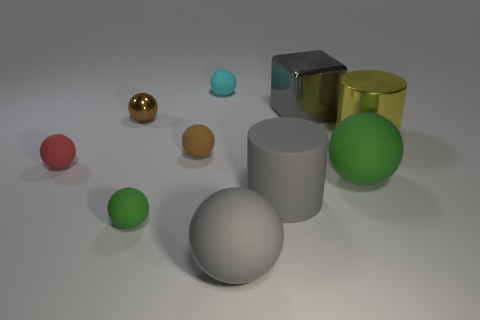There is a green matte sphere that is on the right side of the cyan ball; does it have the same size as the large gray sphere?
Offer a terse response. Yes. There is a big block; is it the same color as the large rubber sphere that is on the right side of the gray cube?
Provide a succinct answer. No. The rubber thing that is the same color as the rubber cylinder is what shape?
Offer a very short reply. Sphere. What is the shape of the tiny metallic thing?
Ensure brevity in your answer.  Sphere. Is the color of the shiny block the same as the shiny cylinder?
Make the answer very short. No. What number of objects are small objects that are to the right of the brown shiny ball or large rubber cylinders?
Give a very brief answer. 4. What is the size of the red sphere that is made of the same material as the cyan sphere?
Provide a succinct answer. Small. Is the number of tiny red things in front of the tiny brown metal ball greater than the number of large matte balls?
Provide a succinct answer. No. There is a tiny cyan matte object; does it have the same shape as the thing right of the large green object?
Keep it short and to the point. No. What number of large things are either gray metallic cubes or brown metal blocks?
Provide a succinct answer. 1. 